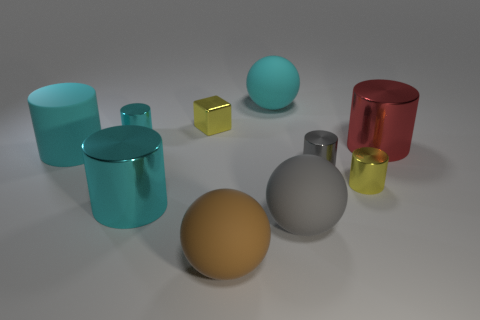What materials are the objects in the image made of? The objects in the image seem to simulate various materials that reflect light differently — the reddish and cyan objects have a metallic sheen, suggesting they could be made of metal. The spheres look like they might be made of a plastic or matte-painted substance, and the small yellow object has a transparency that could resemble glass or a crystalline material. 